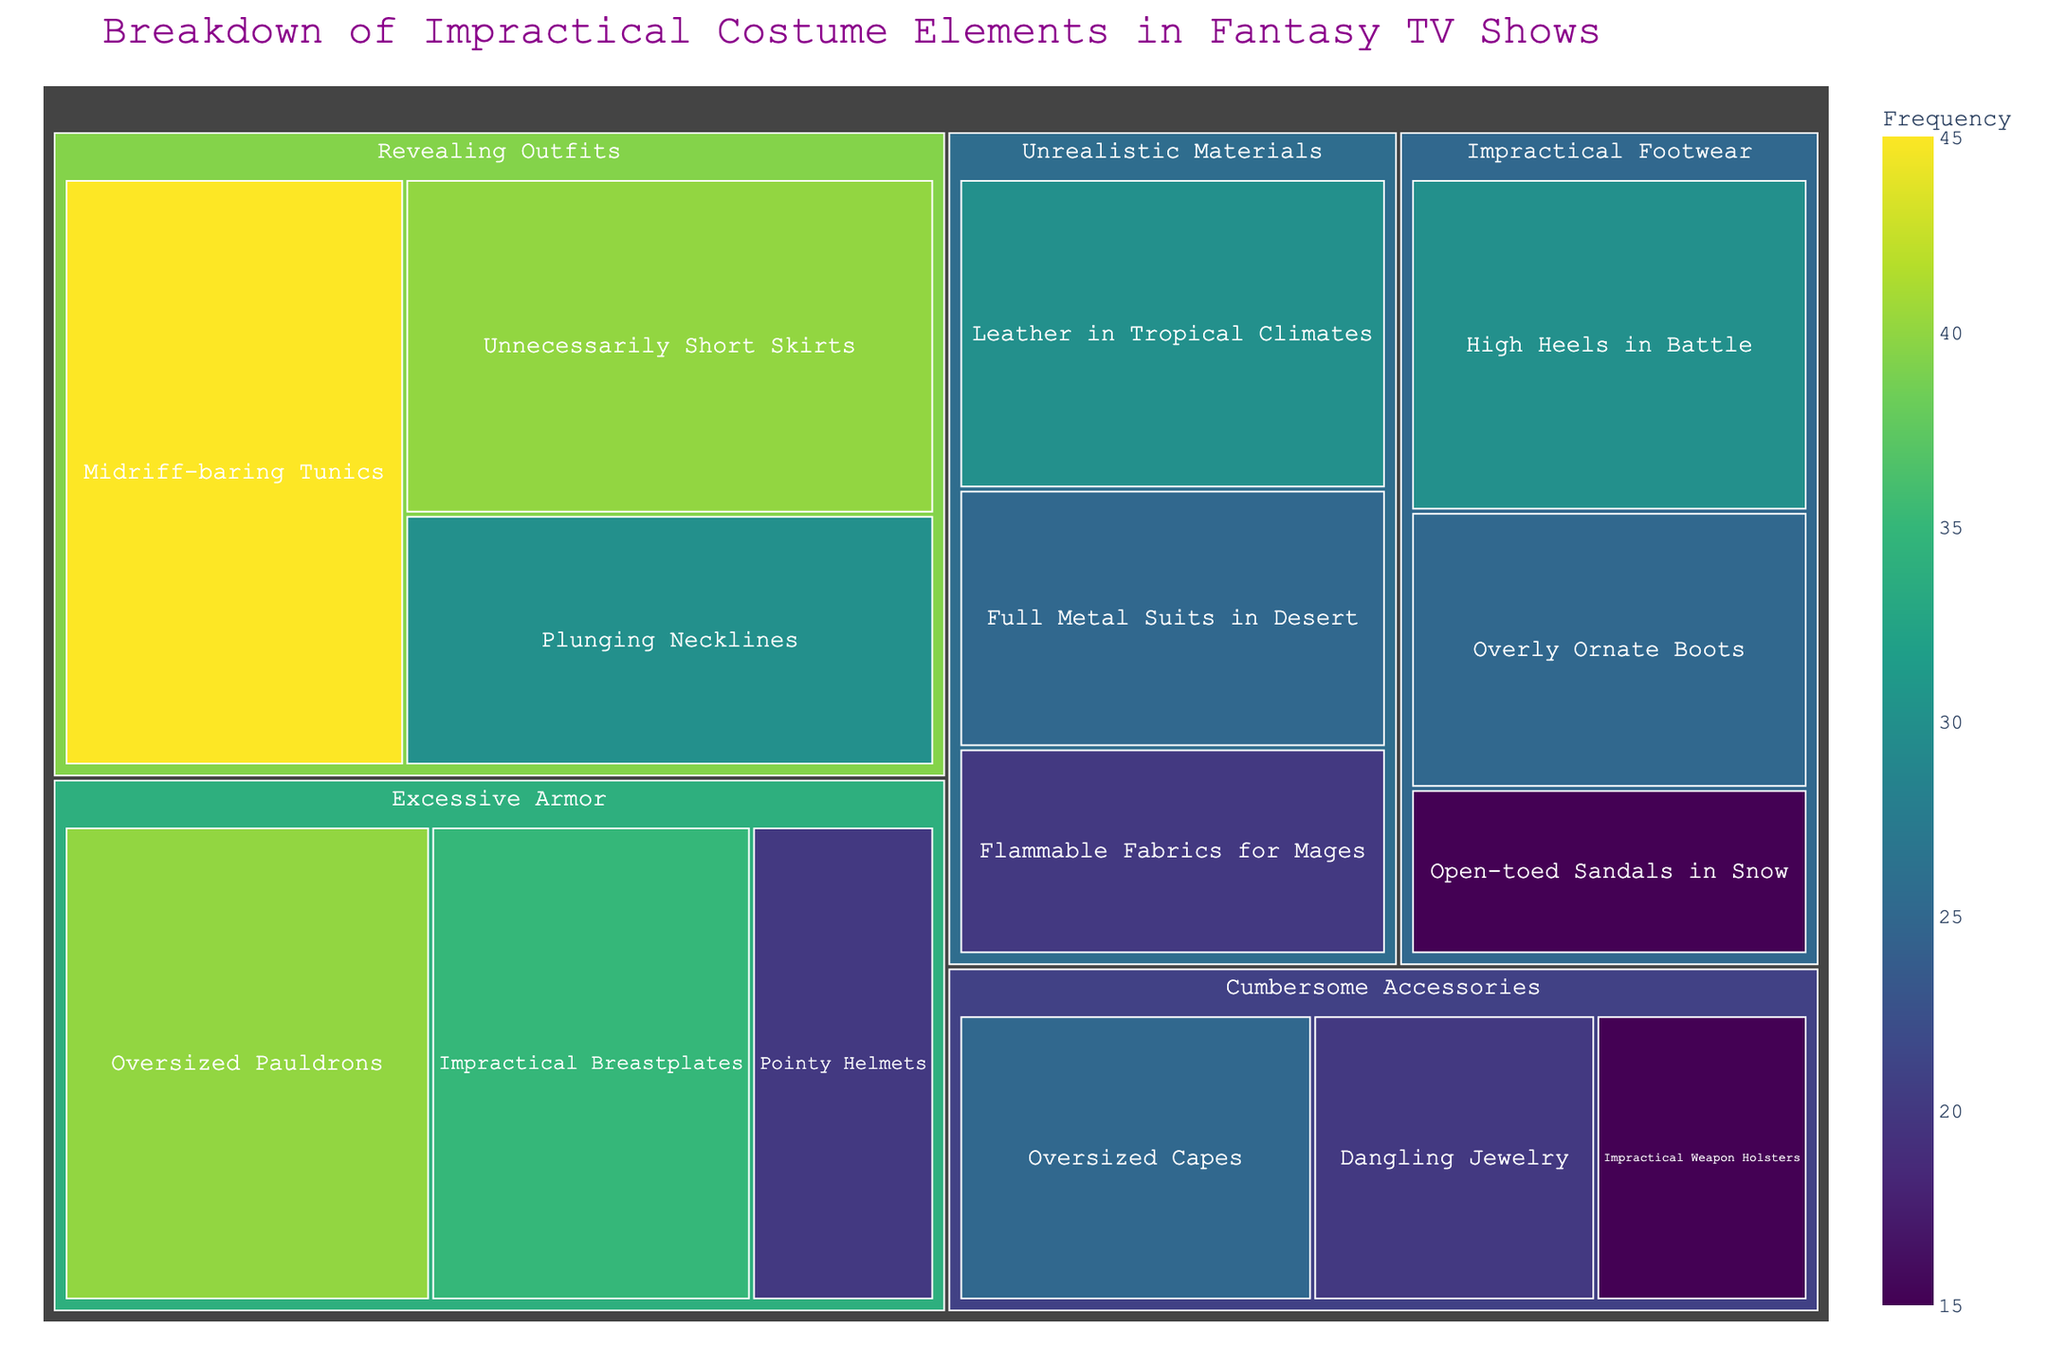What's the title of the treemap? The title is located at the top of the treemap and is usually indicated in a larger font size with a different color for emphasis.
Answer: Breakdown of Impractical Costume Elements in Fantasy TV Shows Which subcategory has the highest frequency? To find the subcategory with the highest frequency, look for the largest block in the treemap or the one with the highest numerical value.
Answer: Midriff-baring Tunics How many subcategories are there in total? Count all the blocks (representing subcategories) within the treemap. Each block corresponds to a specific subcategory.
Answer: 15 What is the total frequency of "Impractical Footwear"? Add the frequencies of all the subcategories under "Impractical Footwear": High Heels in Battle (30), Open-toed Sandals in Snow (15), Overly Ornate Boots (25). 30 + 15 + 25 = 70
Answer: 70 Which category has the most subcategories? Count the number of subcategories in each category.
Answer: Excessive Armor and Revealing Outfits (both have 3 subcategories) How does the frequency of "Plunging Necklines" compare to "Overly Ornate Boots"? Compare the numerical values associated with each subcategory. Plunging Necklines: 30, Overly Ornate Boots: 25. Plunging Necklines have a higher frequency.
Answer: Plunging Necklines > Overly Ornate Boots Which subcategory under "Unrealistic Materials" has the lowest frequency? Look for the smallest block within the category "Unrealistic Materials" or the one with the lowest numerical value.
Answer: Flammable Fabrics for Mages What is the combined frequency of "Oversized Pauldrons" and "Impractical Breastplates"? Add the frequencies of "Oversized Pauldrons" (40) and "Impractical Breastplates" (35). 40 + 35 = 75
Answer: 75 If we consider only the categories "Impractical Footwear" and "Revealing Outfits", which has a higher total frequency? Sum the frequencies for all subcategories under each category. Impractical Footwear: 30 + 15 + 25 = 70. Revealing Outfits: 45 + 30 + 40 = 115.
Answer: Revealing Outfits What's the second-most frequent subcategory under "Cumbersome Accessories"? Identify the subcategories under "Cumbersome Accessories" and arrange them by frequency. Oversized Capes: 25, Dangling Jewelry: 20, Impractical Weapon Holsters: 15. The second-most frequent is Dangling Jewelry.
Answer: Dangling Jewelry 